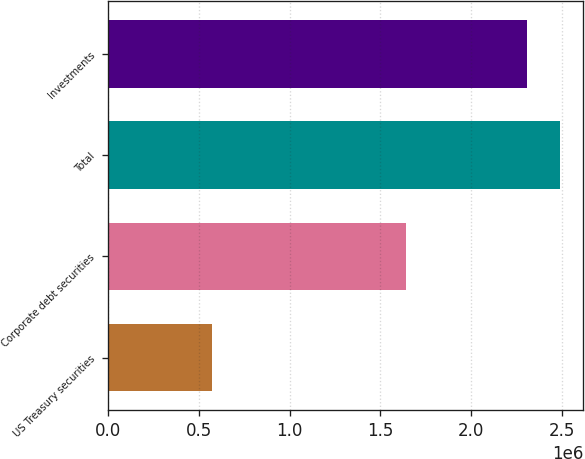Convert chart. <chart><loc_0><loc_0><loc_500><loc_500><bar_chart><fcel>US Treasury securities<fcel>Corporate debt securities<fcel>Total<fcel>Investments<nl><fcel>570313<fcel>1.64384e+06<fcel>2.49359e+06<fcel>2.3074e+06<nl></chart> 